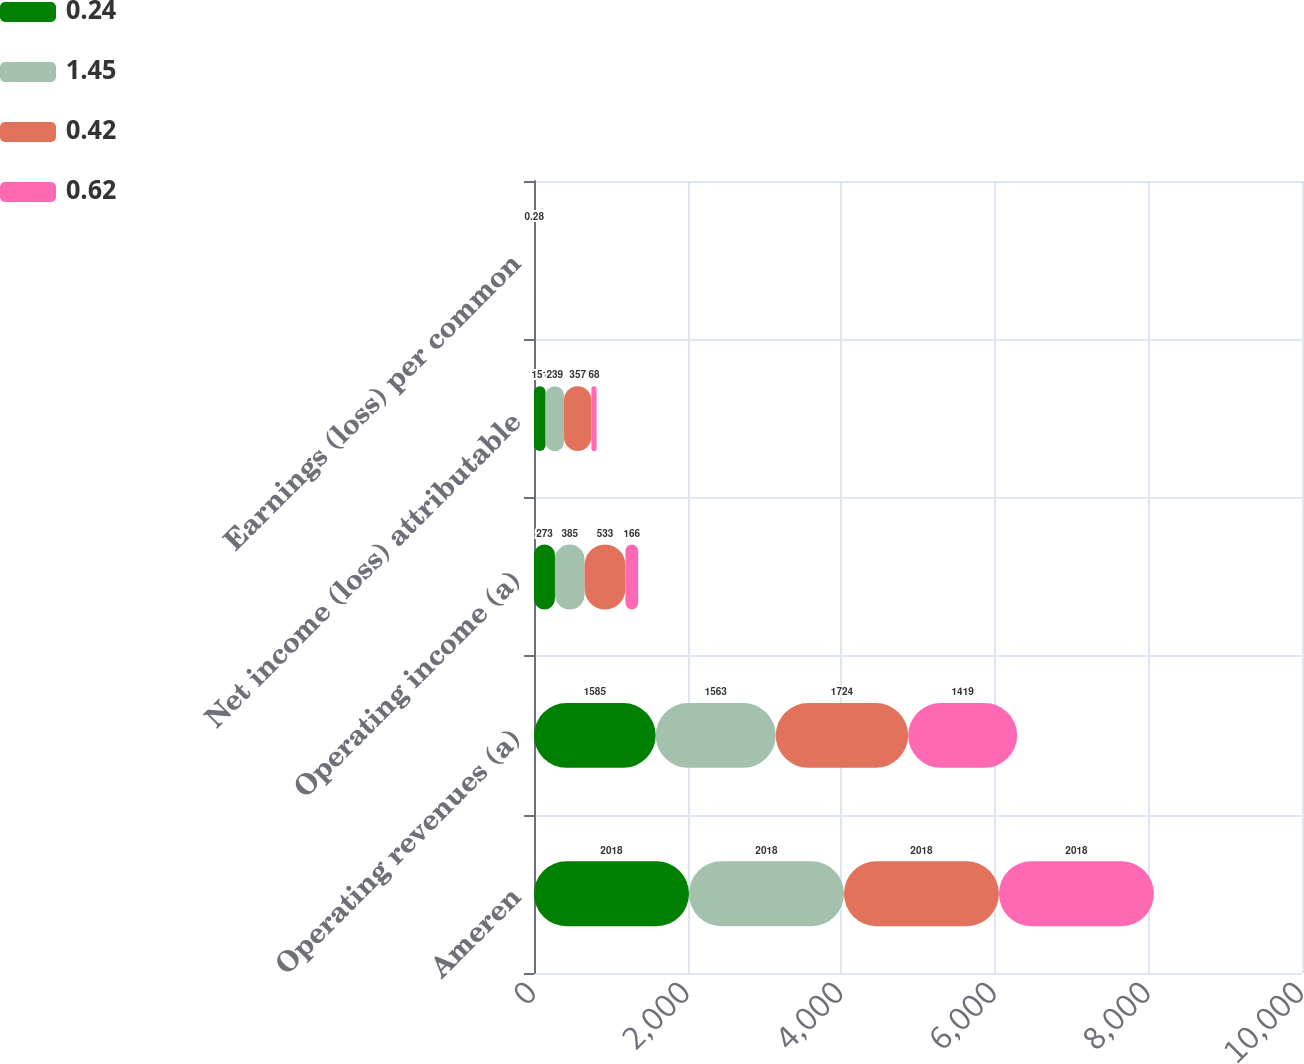Convert chart to OTSL. <chart><loc_0><loc_0><loc_500><loc_500><stacked_bar_chart><ecel><fcel>Ameren<fcel>Operating revenues (a)<fcel>Operating income (a)<fcel>Net income (loss) attributable<fcel>Earnings (loss) per common<nl><fcel>0.24<fcel>2018<fcel>1585<fcel>273<fcel>151<fcel>0.62<nl><fcel>1.45<fcel>2018<fcel>1563<fcel>385<fcel>239<fcel>0.97<nl><fcel>0.42<fcel>2018<fcel>1724<fcel>533<fcel>357<fcel>1.45<nl><fcel>0.62<fcel>2018<fcel>1419<fcel>166<fcel>68<fcel>0.28<nl></chart> 